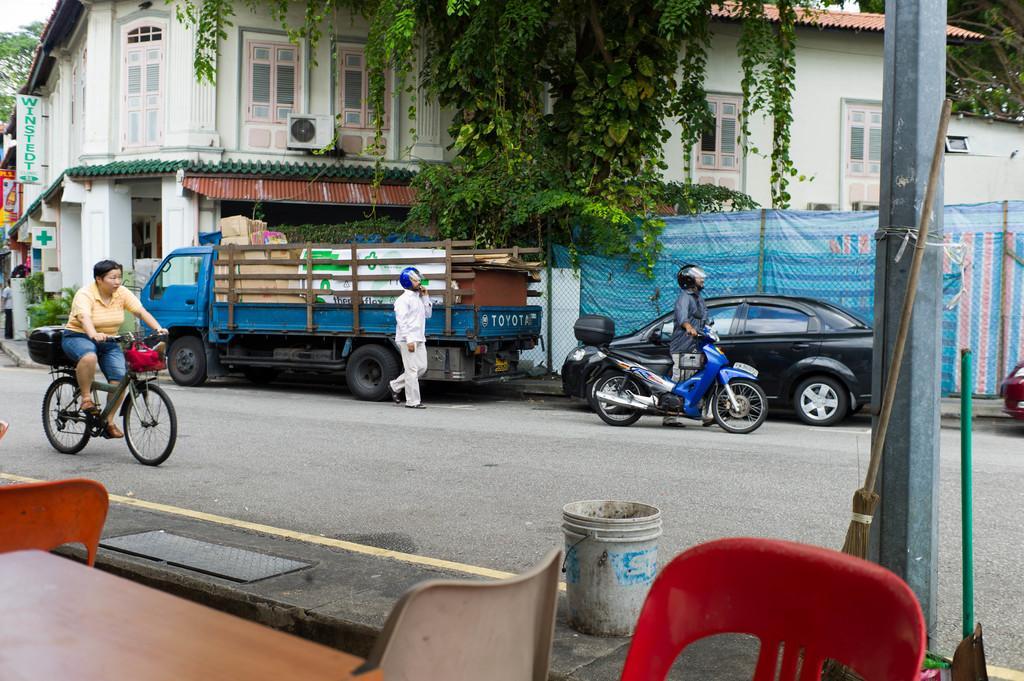Please provide a concise description of this image. In this image I can see few people where one is with his motorcycle and another one is cycling cycle. In the background I can see few vehicles, few trees and few buildings. 